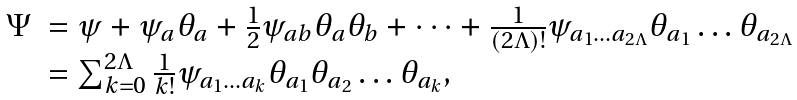Convert formula to latex. <formula><loc_0><loc_0><loc_500><loc_500>\begin{array} { l l } \Psi & = \psi + \psi _ { a } \theta _ { a } + \frac { 1 } { 2 } \psi _ { a b } \theta _ { a } \theta _ { b } + \dots + \frac { 1 } { ( 2 \Lambda ) ! } \psi _ { a _ { 1 } \dots a _ { 2 \Lambda } } \theta _ { a _ { 1 } } \dots \theta _ { a _ { 2 \Lambda } } \\ & = \sum _ { k = 0 } ^ { 2 \Lambda } \frac { 1 } { k ! } \psi _ { a _ { 1 } \dots a _ { k } } \theta _ { a _ { 1 } } \theta _ { a _ { 2 } } \dots \theta _ { a _ { k } } , \end{array}</formula> 